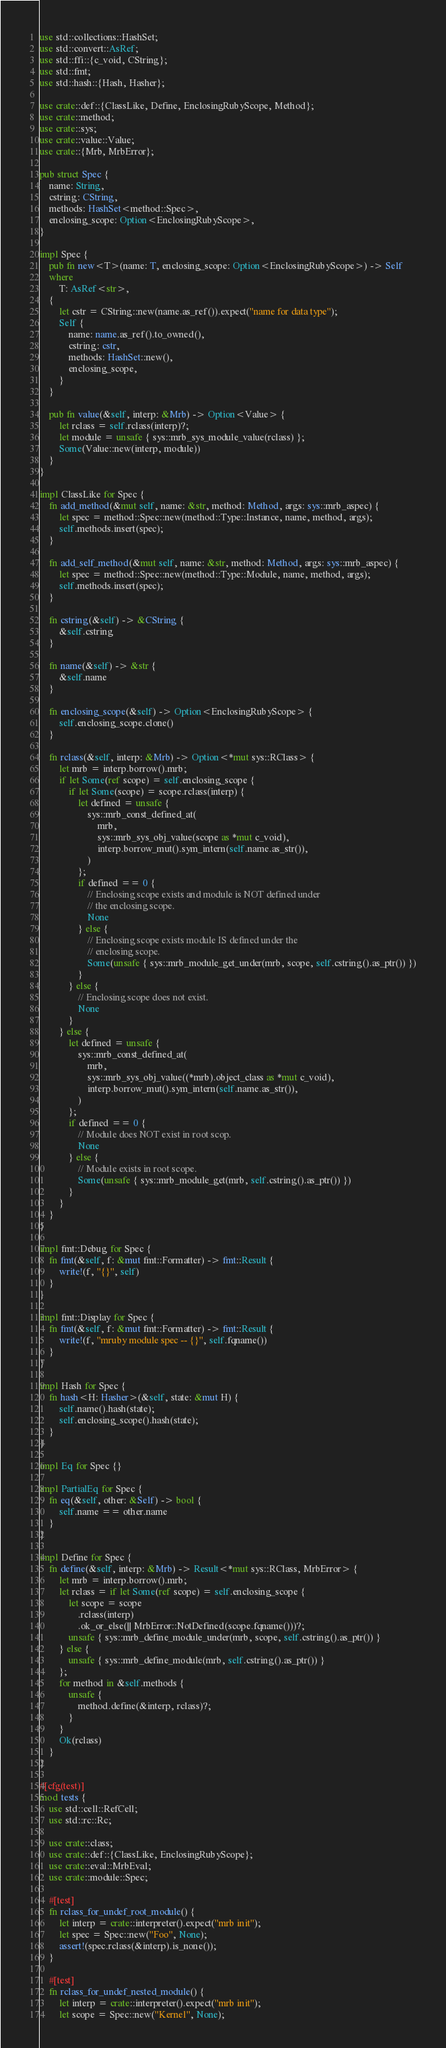<code> <loc_0><loc_0><loc_500><loc_500><_Rust_>use std::collections::HashSet;
use std::convert::AsRef;
use std::ffi::{c_void, CString};
use std::fmt;
use std::hash::{Hash, Hasher};

use crate::def::{ClassLike, Define, EnclosingRubyScope, Method};
use crate::method;
use crate::sys;
use crate::value::Value;
use crate::{Mrb, MrbError};

pub struct Spec {
    name: String,
    cstring: CString,
    methods: HashSet<method::Spec>,
    enclosing_scope: Option<EnclosingRubyScope>,
}

impl Spec {
    pub fn new<T>(name: T, enclosing_scope: Option<EnclosingRubyScope>) -> Self
    where
        T: AsRef<str>,
    {
        let cstr = CString::new(name.as_ref()).expect("name for data type");
        Self {
            name: name.as_ref().to_owned(),
            cstring: cstr,
            methods: HashSet::new(),
            enclosing_scope,
        }
    }

    pub fn value(&self, interp: &Mrb) -> Option<Value> {
        let rclass = self.rclass(interp)?;
        let module = unsafe { sys::mrb_sys_module_value(rclass) };
        Some(Value::new(interp, module))
    }
}

impl ClassLike for Spec {
    fn add_method(&mut self, name: &str, method: Method, args: sys::mrb_aspec) {
        let spec = method::Spec::new(method::Type::Instance, name, method, args);
        self.methods.insert(spec);
    }

    fn add_self_method(&mut self, name: &str, method: Method, args: sys::mrb_aspec) {
        let spec = method::Spec::new(method::Type::Module, name, method, args);
        self.methods.insert(spec);
    }

    fn cstring(&self) -> &CString {
        &self.cstring
    }

    fn name(&self) -> &str {
        &self.name
    }

    fn enclosing_scope(&self) -> Option<EnclosingRubyScope> {
        self.enclosing_scope.clone()
    }

    fn rclass(&self, interp: &Mrb) -> Option<*mut sys::RClass> {
        let mrb = interp.borrow().mrb;
        if let Some(ref scope) = self.enclosing_scope {
            if let Some(scope) = scope.rclass(interp) {
                let defined = unsafe {
                    sys::mrb_const_defined_at(
                        mrb,
                        sys::mrb_sys_obj_value(scope as *mut c_void),
                        interp.borrow_mut().sym_intern(self.name.as_str()),
                    )
                };
                if defined == 0 {
                    // Enclosing scope exists and module is NOT defined under
                    // the enclosing scope.
                    None
                } else {
                    // Enclosing scope exists module IS defined under the
                    // enclosing scope.
                    Some(unsafe { sys::mrb_module_get_under(mrb, scope, self.cstring().as_ptr()) })
                }
            } else {
                // Enclosing scope does not exist.
                None
            }
        } else {
            let defined = unsafe {
                sys::mrb_const_defined_at(
                    mrb,
                    sys::mrb_sys_obj_value((*mrb).object_class as *mut c_void),
                    interp.borrow_mut().sym_intern(self.name.as_str()),
                )
            };
            if defined == 0 {
                // Module does NOT exist in root scop.
                None
            } else {
                // Module exists in root scope.
                Some(unsafe { sys::mrb_module_get(mrb, self.cstring().as_ptr()) })
            }
        }
    }
}

impl fmt::Debug for Spec {
    fn fmt(&self, f: &mut fmt::Formatter) -> fmt::Result {
        write!(f, "{}", self)
    }
}

impl fmt::Display for Spec {
    fn fmt(&self, f: &mut fmt::Formatter) -> fmt::Result {
        write!(f, "mruby module spec -- {}", self.fqname())
    }
}

impl Hash for Spec {
    fn hash<H: Hasher>(&self, state: &mut H) {
        self.name().hash(state);
        self.enclosing_scope().hash(state);
    }
}

impl Eq for Spec {}

impl PartialEq for Spec {
    fn eq(&self, other: &Self) -> bool {
        self.name == other.name
    }
}

impl Define for Spec {
    fn define(&self, interp: &Mrb) -> Result<*mut sys::RClass, MrbError> {
        let mrb = interp.borrow().mrb;
        let rclass = if let Some(ref scope) = self.enclosing_scope {
            let scope = scope
                .rclass(interp)
                .ok_or_else(|| MrbError::NotDefined(scope.fqname()))?;
            unsafe { sys::mrb_define_module_under(mrb, scope, self.cstring().as_ptr()) }
        } else {
            unsafe { sys::mrb_define_module(mrb, self.cstring().as_ptr()) }
        };
        for method in &self.methods {
            unsafe {
                method.define(&interp, rclass)?;
            }
        }
        Ok(rclass)
    }
}

#[cfg(test)]
mod tests {
    use std::cell::RefCell;
    use std::rc::Rc;

    use crate::class;
    use crate::def::{ClassLike, EnclosingRubyScope};
    use crate::eval::MrbEval;
    use crate::module::Spec;

    #[test]
    fn rclass_for_undef_root_module() {
        let interp = crate::interpreter().expect("mrb init");
        let spec = Spec::new("Foo", None);
        assert!(spec.rclass(&interp).is_none());
    }

    #[test]
    fn rclass_for_undef_nested_module() {
        let interp = crate::interpreter().expect("mrb init");
        let scope = Spec::new("Kernel", None);</code> 